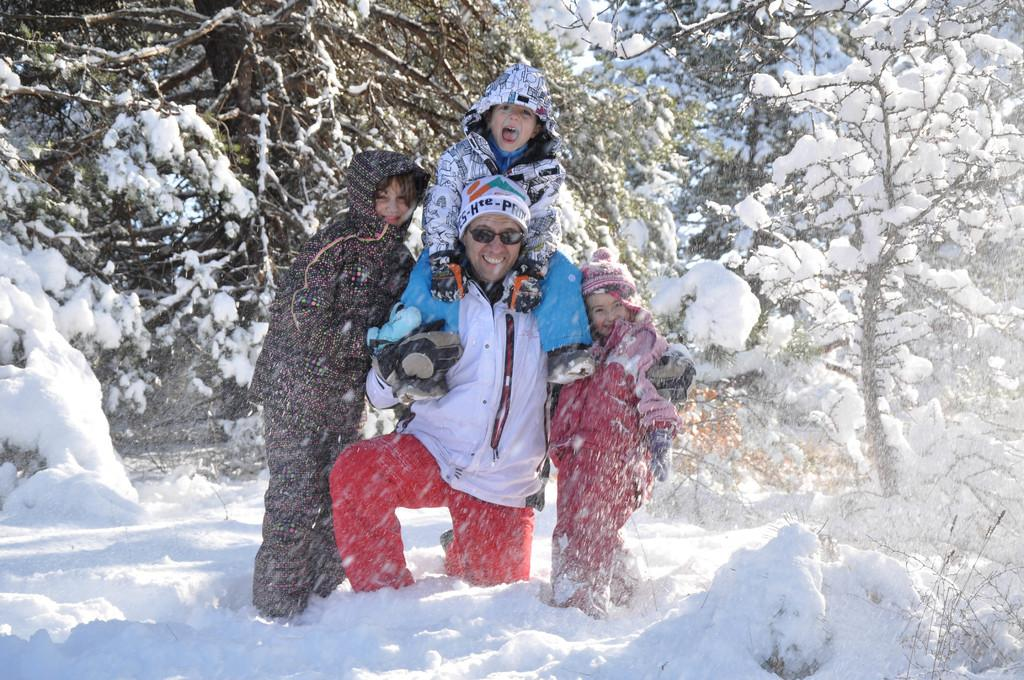How many people are in the image? There are four persons in the image. What is the facial expression of the people in the image? The persons are smiling. What can be seen in the background of the image? There are trees in the background of the image. What is the condition of the trees in the image? The trees are covered with snow. What type of lamp is hanging from the tree in the image? There is no lamp hanging from the tree in the image; the trees are covered with snow. What board game are the persons playing in the image? There is no board game visible in the image; the persons are simply smiling. 